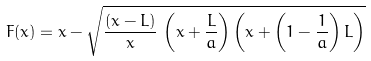<formula> <loc_0><loc_0><loc_500><loc_500>F ( x ) = x - \sqrt { \frac { ( x - L ) } { x } \, \left ( x + \frac { L } { a } \right ) \left ( x + \left ( 1 - \frac { 1 } { a } \right ) L \right ) }</formula> 